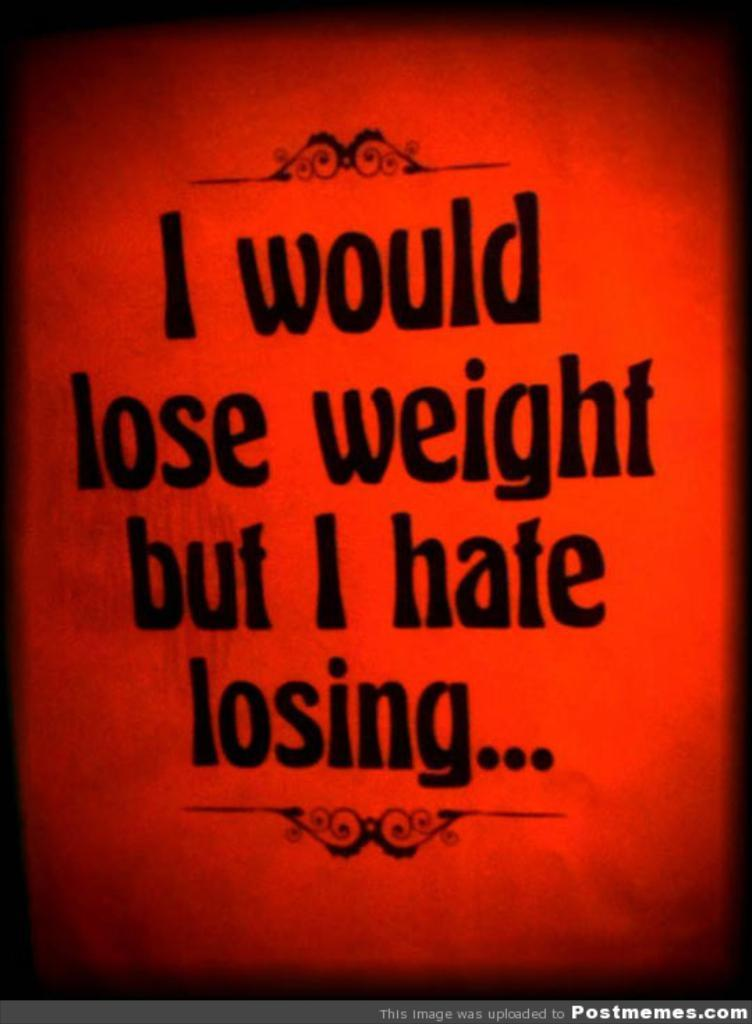Provide a one-sentence caption for the provided image. A red poster that says I would lose weight but I hate losing. 